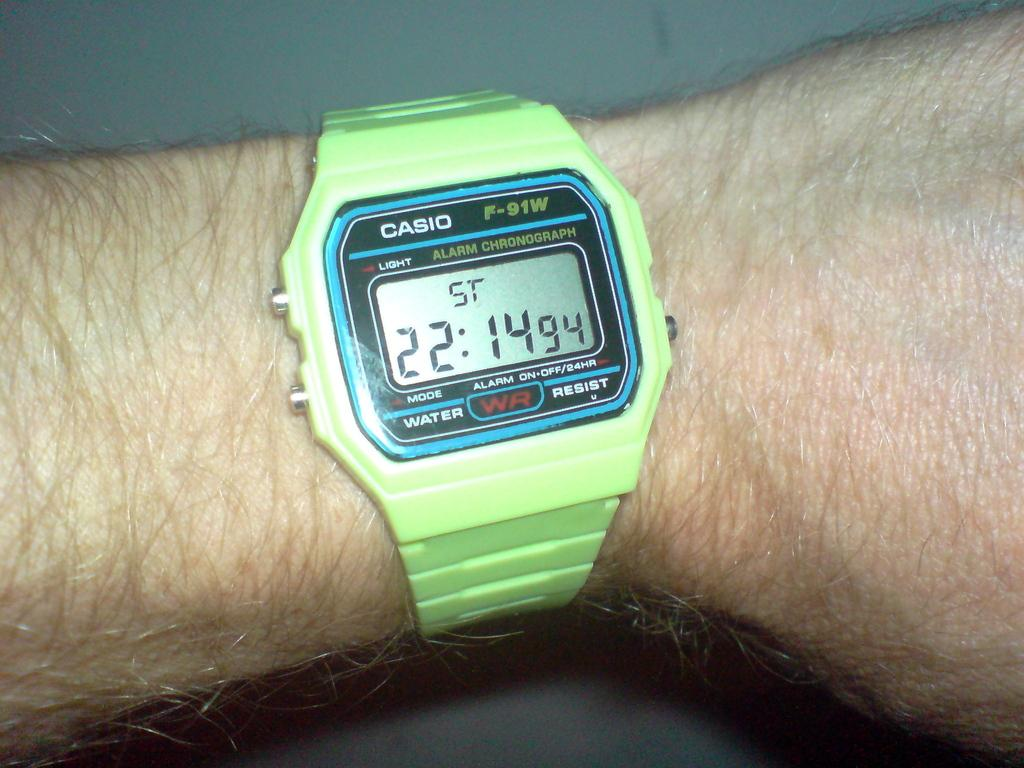<image>
Give a short and clear explanation of the subsequent image. A man wearing a light green Casio watch on his wrist. 